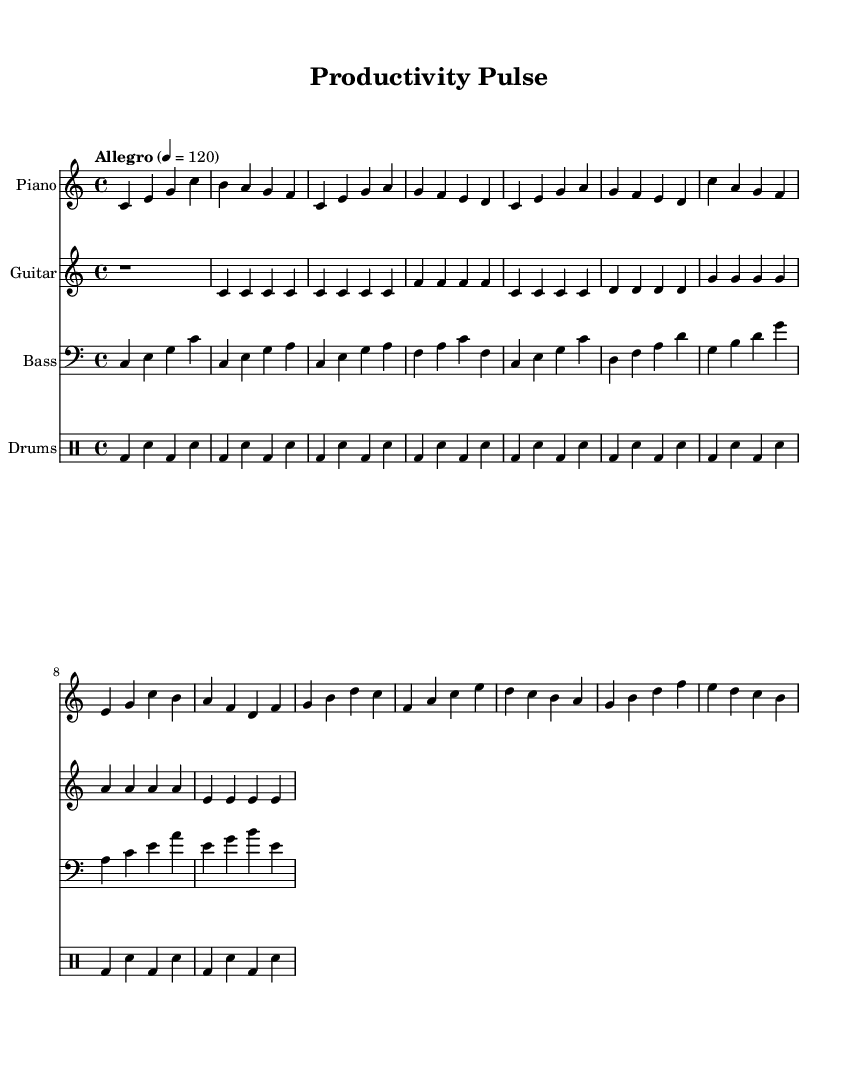What is the key signature of this music? The key signature is C major, which has no sharps or flats.
Answer: C major What is the time signature of the piece? The time signature is indicated at the beginning of the music, showing it is in 4/4 time, meaning there are four beats in each measure.
Answer: 4/4 What is the tempo marking for this piece? The tempo marking states "Allegro" with a metronome mark of 120, indicating a fast pace.
Answer: Allegro 4 = 120 How many measures are there in the chorus section? By reviewing the chorus part, we can count the measures, identifying that the chorus consists of four measures: one for each line.
Answer: 4 What correlates the piano and guitar parts in the verse? Both parts in the verse feature a repeated pattern: the piano plays a series of notes while the guitar plays consistent quarter notes each measure, creating a cohesive sound.
Answer: Repeated pattern What is the pattern of the bass notes in the chorus? The bass notes follow a structured pattern, predominantly hitting the root notes of the chords played in the piano and guitar, aligning with the harmonic foundation of the piece.
Answer: Root notes How does the drum pattern support the energy of the chorus? The drum pattern uses consistent bass drum hits on the downbeats interspersed with snare drum hits, driving the rhythmic energy, matching the upbeat feel of the chorus.
Answer: Rhythmic energy 